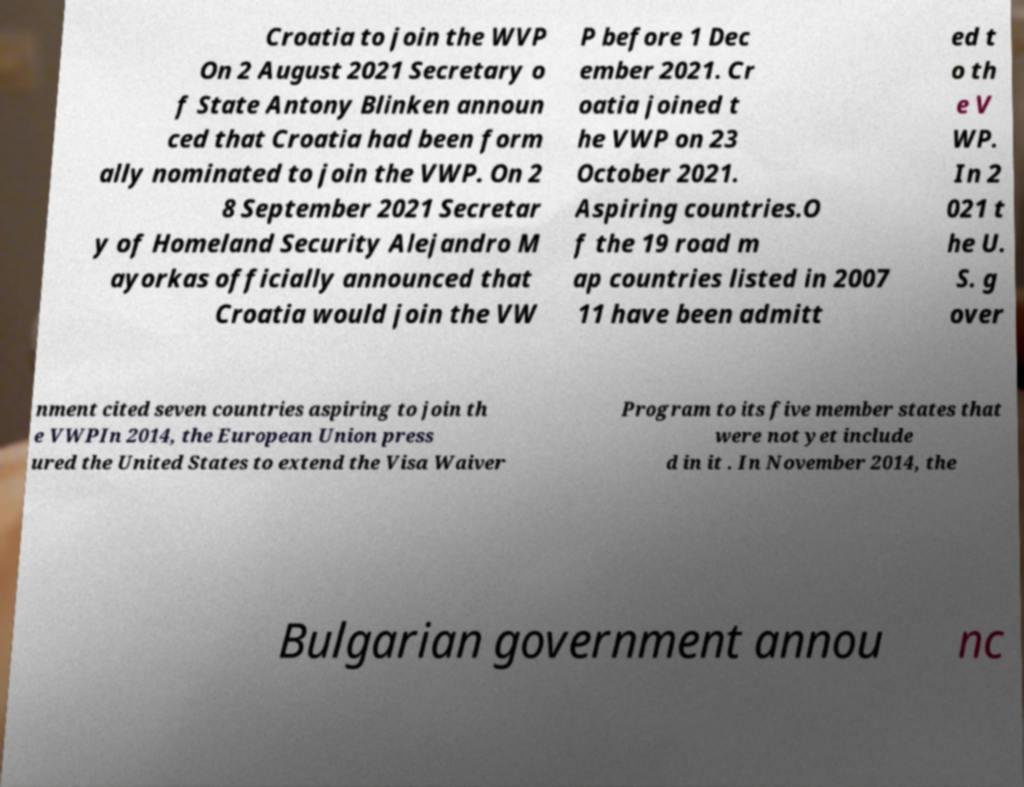What messages or text are displayed in this image? I need them in a readable, typed format. Croatia to join the WVP On 2 August 2021 Secretary o f State Antony Blinken announ ced that Croatia had been form ally nominated to join the VWP. On 2 8 September 2021 Secretar y of Homeland Security Alejandro M ayorkas officially announced that Croatia would join the VW P before 1 Dec ember 2021. Cr oatia joined t he VWP on 23 October 2021. Aspiring countries.O f the 19 road m ap countries listed in 2007 11 have been admitt ed t o th e V WP. In 2 021 t he U. S. g over nment cited seven countries aspiring to join th e VWPIn 2014, the European Union press ured the United States to extend the Visa Waiver Program to its five member states that were not yet include d in it . In November 2014, the Bulgarian government annou nc 